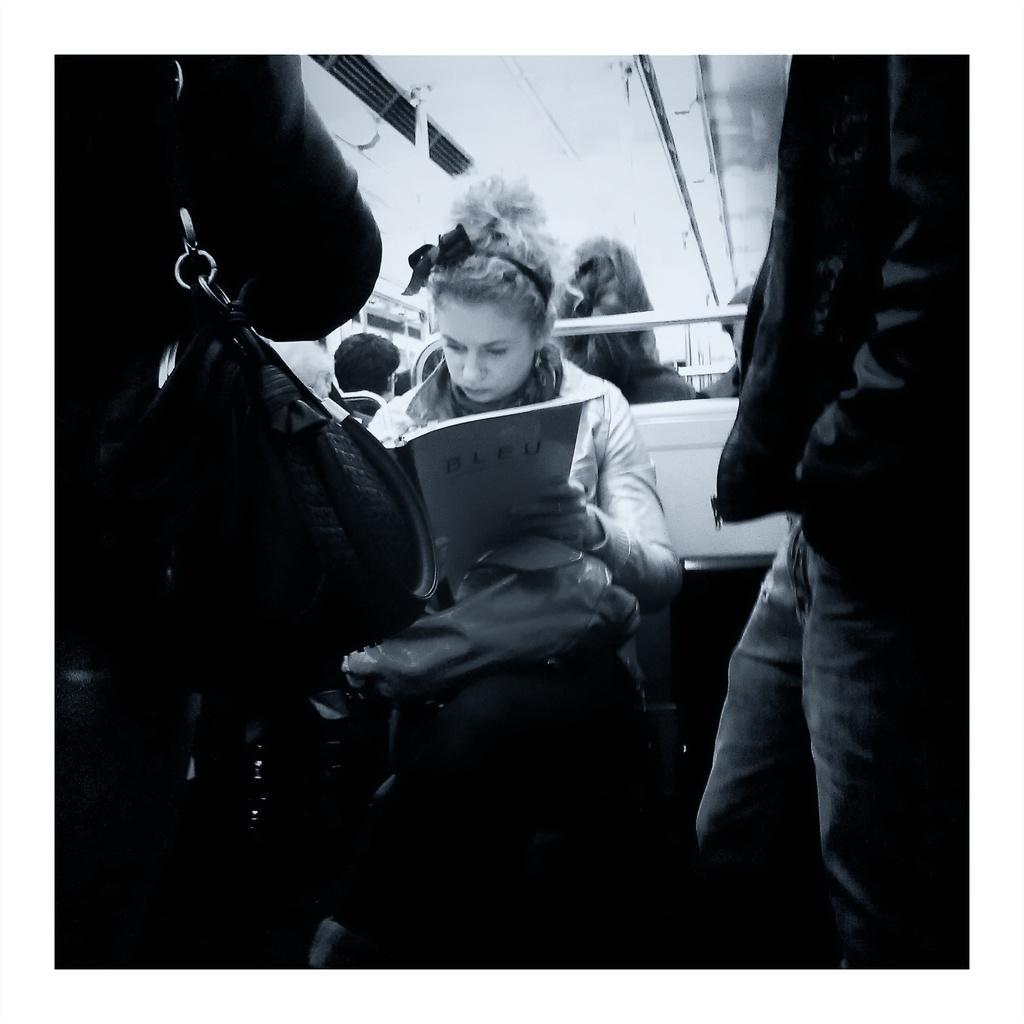In one or two sentences, can you explain what this image depicts? In this picture there are people, among them there is a woman sitting and holding a book and we can see rod. On the left side of the image there is a person carrying a bag. 